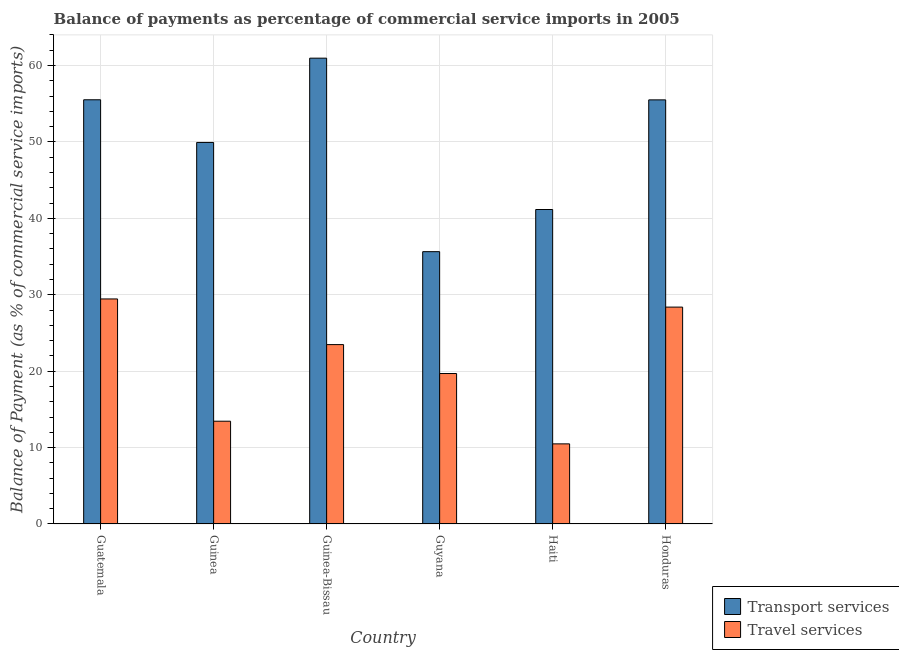How many different coloured bars are there?
Give a very brief answer. 2. What is the label of the 6th group of bars from the left?
Give a very brief answer. Honduras. In how many cases, is the number of bars for a given country not equal to the number of legend labels?
Ensure brevity in your answer.  0. What is the balance of payments of transport services in Honduras?
Offer a very short reply. 55.5. Across all countries, what is the maximum balance of payments of travel services?
Provide a succinct answer. 29.45. Across all countries, what is the minimum balance of payments of travel services?
Make the answer very short. 10.48. In which country was the balance of payments of travel services maximum?
Provide a succinct answer. Guatemala. In which country was the balance of payments of transport services minimum?
Make the answer very short. Guyana. What is the total balance of payments of travel services in the graph?
Your answer should be very brief. 124.93. What is the difference between the balance of payments of transport services in Guinea and that in Honduras?
Offer a very short reply. -5.57. What is the difference between the balance of payments of transport services in Guyana and the balance of payments of travel services in Haiti?
Ensure brevity in your answer.  25.15. What is the average balance of payments of transport services per country?
Make the answer very short. 49.78. What is the difference between the balance of payments of travel services and balance of payments of transport services in Guatemala?
Your answer should be compact. -26.06. In how many countries, is the balance of payments of travel services greater than 46 %?
Make the answer very short. 0. What is the ratio of the balance of payments of travel services in Guinea-Bissau to that in Haiti?
Your answer should be compact. 2.24. Is the balance of payments of transport services in Guyana less than that in Haiti?
Offer a terse response. Yes. Is the difference between the balance of payments of transport services in Guyana and Honduras greater than the difference between the balance of payments of travel services in Guyana and Honduras?
Ensure brevity in your answer.  No. What is the difference between the highest and the second highest balance of payments of transport services?
Ensure brevity in your answer.  5.45. What is the difference between the highest and the lowest balance of payments of transport services?
Ensure brevity in your answer.  25.32. What does the 2nd bar from the left in Guinea-Bissau represents?
Ensure brevity in your answer.  Travel services. What does the 1st bar from the right in Honduras represents?
Offer a terse response. Travel services. Are the values on the major ticks of Y-axis written in scientific E-notation?
Make the answer very short. No. How are the legend labels stacked?
Your response must be concise. Vertical. What is the title of the graph?
Give a very brief answer. Balance of payments as percentage of commercial service imports in 2005. Does "Lowest 10% of population" appear as one of the legend labels in the graph?
Your answer should be very brief. No. What is the label or title of the X-axis?
Offer a very short reply. Country. What is the label or title of the Y-axis?
Keep it short and to the point. Balance of Payment (as % of commercial service imports). What is the Balance of Payment (as % of commercial service imports) in Transport services in Guatemala?
Ensure brevity in your answer.  55.52. What is the Balance of Payment (as % of commercial service imports) in Travel services in Guatemala?
Make the answer very short. 29.45. What is the Balance of Payment (as % of commercial service imports) of Transport services in Guinea?
Ensure brevity in your answer.  49.93. What is the Balance of Payment (as % of commercial service imports) of Travel services in Guinea?
Provide a short and direct response. 13.45. What is the Balance of Payment (as % of commercial service imports) of Transport services in Guinea-Bissau?
Give a very brief answer. 60.96. What is the Balance of Payment (as % of commercial service imports) in Travel services in Guinea-Bissau?
Give a very brief answer. 23.48. What is the Balance of Payment (as % of commercial service imports) of Transport services in Guyana?
Your response must be concise. 35.64. What is the Balance of Payment (as % of commercial service imports) in Travel services in Guyana?
Make the answer very short. 19.69. What is the Balance of Payment (as % of commercial service imports) in Transport services in Haiti?
Your response must be concise. 41.16. What is the Balance of Payment (as % of commercial service imports) of Travel services in Haiti?
Provide a short and direct response. 10.48. What is the Balance of Payment (as % of commercial service imports) in Transport services in Honduras?
Offer a terse response. 55.5. What is the Balance of Payment (as % of commercial service imports) of Travel services in Honduras?
Give a very brief answer. 28.38. Across all countries, what is the maximum Balance of Payment (as % of commercial service imports) of Transport services?
Offer a very short reply. 60.96. Across all countries, what is the maximum Balance of Payment (as % of commercial service imports) in Travel services?
Offer a very short reply. 29.45. Across all countries, what is the minimum Balance of Payment (as % of commercial service imports) in Transport services?
Provide a short and direct response. 35.64. Across all countries, what is the minimum Balance of Payment (as % of commercial service imports) of Travel services?
Your response must be concise. 10.48. What is the total Balance of Payment (as % of commercial service imports) in Transport services in the graph?
Your answer should be compact. 298.7. What is the total Balance of Payment (as % of commercial service imports) of Travel services in the graph?
Ensure brevity in your answer.  124.93. What is the difference between the Balance of Payment (as % of commercial service imports) in Transport services in Guatemala and that in Guinea?
Offer a very short reply. 5.58. What is the difference between the Balance of Payment (as % of commercial service imports) in Travel services in Guatemala and that in Guinea?
Your answer should be very brief. 16. What is the difference between the Balance of Payment (as % of commercial service imports) in Transport services in Guatemala and that in Guinea-Bissau?
Your answer should be compact. -5.45. What is the difference between the Balance of Payment (as % of commercial service imports) of Travel services in Guatemala and that in Guinea-Bissau?
Provide a succinct answer. 5.98. What is the difference between the Balance of Payment (as % of commercial service imports) in Transport services in Guatemala and that in Guyana?
Offer a very short reply. 19.88. What is the difference between the Balance of Payment (as % of commercial service imports) of Travel services in Guatemala and that in Guyana?
Make the answer very short. 9.76. What is the difference between the Balance of Payment (as % of commercial service imports) of Transport services in Guatemala and that in Haiti?
Your response must be concise. 14.36. What is the difference between the Balance of Payment (as % of commercial service imports) of Travel services in Guatemala and that in Haiti?
Your answer should be very brief. 18.97. What is the difference between the Balance of Payment (as % of commercial service imports) of Transport services in Guatemala and that in Honduras?
Make the answer very short. 0.01. What is the difference between the Balance of Payment (as % of commercial service imports) in Travel services in Guatemala and that in Honduras?
Provide a short and direct response. 1.07. What is the difference between the Balance of Payment (as % of commercial service imports) of Transport services in Guinea and that in Guinea-Bissau?
Make the answer very short. -11.03. What is the difference between the Balance of Payment (as % of commercial service imports) of Travel services in Guinea and that in Guinea-Bissau?
Your answer should be very brief. -10.03. What is the difference between the Balance of Payment (as % of commercial service imports) in Transport services in Guinea and that in Guyana?
Provide a succinct answer. 14.3. What is the difference between the Balance of Payment (as % of commercial service imports) in Travel services in Guinea and that in Guyana?
Offer a terse response. -6.24. What is the difference between the Balance of Payment (as % of commercial service imports) in Transport services in Guinea and that in Haiti?
Offer a terse response. 8.78. What is the difference between the Balance of Payment (as % of commercial service imports) in Travel services in Guinea and that in Haiti?
Provide a succinct answer. 2.97. What is the difference between the Balance of Payment (as % of commercial service imports) of Transport services in Guinea and that in Honduras?
Your answer should be compact. -5.57. What is the difference between the Balance of Payment (as % of commercial service imports) in Travel services in Guinea and that in Honduras?
Your answer should be compact. -14.93. What is the difference between the Balance of Payment (as % of commercial service imports) in Transport services in Guinea-Bissau and that in Guyana?
Offer a very short reply. 25.32. What is the difference between the Balance of Payment (as % of commercial service imports) in Travel services in Guinea-Bissau and that in Guyana?
Offer a terse response. 3.79. What is the difference between the Balance of Payment (as % of commercial service imports) in Transport services in Guinea-Bissau and that in Haiti?
Provide a succinct answer. 19.81. What is the difference between the Balance of Payment (as % of commercial service imports) of Travel services in Guinea-Bissau and that in Haiti?
Offer a terse response. 12.99. What is the difference between the Balance of Payment (as % of commercial service imports) of Transport services in Guinea-Bissau and that in Honduras?
Offer a terse response. 5.46. What is the difference between the Balance of Payment (as % of commercial service imports) of Travel services in Guinea-Bissau and that in Honduras?
Provide a short and direct response. -4.91. What is the difference between the Balance of Payment (as % of commercial service imports) of Transport services in Guyana and that in Haiti?
Your response must be concise. -5.52. What is the difference between the Balance of Payment (as % of commercial service imports) in Travel services in Guyana and that in Haiti?
Offer a terse response. 9.2. What is the difference between the Balance of Payment (as % of commercial service imports) in Transport services in Guyana and that in Honduras?
Keep it short and to the point. -19.87. What is the difference between the Balance of Payment (as % of commercial service imports) in Travel services in Guyana and that in Honduras?
Ensure brevity in your answer.  -8.69. What is the difference between the Balance of Payment (as % of commercial service imports) in Transport services in Haiti and that in Honduras?
Offer a terse response. -14.35. What is the difference between the Balance of Payment (as % of commercial service imports) of Travel services in Haiti and that in Honduras?
Provide a succinct answer. -17.9. What is the difference between the Balance of Payment (as % of commercial service imports) in Transport services in Guatemala and the Balance of Payment (as % of commercial service imports) in Travel services in Guinea?
Your answer should be very brief. 42.07. What is the difference between the Balance of Payment (as % of commercial service imports) of Transport services in Guatemala and the Balance of Payment (as % of commercial service imports) of Travel services in Guinea-Bissau?
Make the answer very short. 32.04. What is the difference between the Balance of Payment (as % of commercial service imports) in Transport services in Guatemala and the Balance of Payment (as % of commercial service imports) in Travel services in Guyana?
Your answer should be very brief. 35.83. What is the difference between the Balance of Payment (as % of commercial service imports) of Transport services in Guatemala and the Balance of Payment (as % of commercial service imports) of Travel services in Haiti?
Offer a terse response. 45.03. What is the difference between the Balance of Payment (as % of commercial service imports) of Transport services in Guatemala and the Balance of Payment (as % of commercial service imports) of Travel services in Honduras?
Provide a short and direct response. 27.13. What is the difference between the Balance of Payment (as % of commercial service imports) of Transport services in Guinea and the Balance of Payment (as % of commercial service imports) of Travel services in Guinea-Bissau?
Ensure brevity in your answer.  26.46. What is the difference between the Balance of Payment (as % of commercial service imports) in Transport services in Guinea and the Balance of Payment (as % of commercial service imports) in Travel services in Guyana?
Offer a terse response. 30.24. What is the difference between the Balance of Payment (as % of commercial service imports) of Transport services in Guinea and the Balance of Payment (as % of commercial service imports) of Travel services in Haiti?
Your answer should be very brief. 39.45. What is the difference between the Balance of Payment (as % of commercial service imports) in Transport services in Guinea and the Balance of Payment (as % of commercial service imports) in Travel services in Honduras?
Your answer should be compact. 21.55. What is the difference between the Balance of Payment (as % of commercial service imports) of Transport services in Guinea-Bissau and the Balance of Payment (as % of commercial service imports) of Travel services in Guyana?
Ensure brevity in your answer.  41.27. What is the difference between the Balance of Payment (as % of commercial service imports) of Transport services in Guinea-Bissau and the Balance of Payment (as % of commercial service imports) of Travel services in Haiti?
Offer a very short reply. 50.48. What is the difference between the Balance of Payment (as % of commercial service imports) in Transport services in Guinea-Bissau and the Balance of Payment (as % of commercial service imports) in Travel services in Honduras?
Offer a terse response. 32.58. What is the difference between the Balance of Payment (as % of commercial service imports) in Transport services in Guyana and the Balance of Payment (as % of commercial service imports) in Travel services in Haiti?
Provide a succinct answer. 25.15. What is the difference between the Balance of Payment (as % of commercial service imports) of Transport services in Guyana and the Balance of Payment (as % of commercial service imports) of Travel services in Honduras?
Make the answer very short. 7.25. What is the difference between the Balance of Payment (as % of commercial service imports) of Transport services in Haiti and the Balance of Payment (as % of commercial service imports) of Travel services in Honduras?
Offer a terse response. 12.77. What is the average Balance of Payment (as % of commercial service imports) of Transport services per country?
Provide a succinct answer. 49.78. What is the average Balance of Payment (as % of commercial service imports) of Travel services per country?
Offer a terse response. 20.82. What is the difference between the Balance of Payment (as % of commercial service imports) in Transport services and Balance of Payment (as % of commercial service imports) in Travel services in Guatemala?
Provide a short and direct response. 26.06. What is the difference between the Balance of Payment (as % of commercial service imports) in Transport services and Balance of Payment (as % of commercial service imports) in Travel services in Guinea?
Provide a short and direct response. 36.48. What is the difference between the Balance of Payment (as % of commercial service imports) in Transport services and Balance of Payment (as % of commercial service imports) in Travel services in Guinea-Bissau?
Offer a very short reply. 37.49. What is the difference between the Balance of Payment (as % of commercial service imports) of Transport services and Balance of Payment (as % of commercial service imports) of Travel services in Guyana?
Make the answer very short. 15.95. What is the difference between the Balance of Payment (as % of commercial service imports) in Transport services and Balance of Payment (as % of commercial service imports) in Travel services in Haiti?
Your answer should be compact. 30.67. What is the difference between the Balance of Payment (as % of commercial service imports) of Transport services and Balance of Payment (as % of commercial service imports) of Travel services in Honduras?
Make the answer very short. 27.12. What is the ratio of the Balance of Payment (as % of commercial service imports) of Transport services in Guatemala to that in Guinea?
Your response must be concise. 1.11. What is the ratio of the Balance of Payment (as % of commercial service imports) in Travel services in Guatemala to that in Guinea?
Give a very brief answer. 2.19. What is the ratio of the Balance of Payment (as % of commercial service imports) of Transport services in Guatemala to that in Guinea-Bissau?
Your answer should be compact. 0.91. What is the ratio of the Balance of Payment (as % of commercial service imports) in Travel services in Guatemala to that in Guinea-Bissau?
Provide a succinct answer. 1.25. What is the ratio of the Balance of Payment (as % of commercial service imports) of Transport services in Guatemala to that in Guyana?
Provide a succinct answer. 1.56. What is the ratio of the Balance of Payment (as % of commercial service imports) of Travel services in Guatemala to that in Guyana?
Offer a terse response. 1.5. What is the ratio of the Balance of Payment (as % of commercial service imports) of Transport services in Guatemala to that in Haiti?
Give a very brief answer. 1.35. What is the ratio of the Balance of Payment (as % of commercial service imports) of Travel services in Guatemala to that in Haiti?
Your answer should be compact. 2.81. What is the ratio of the Balance of Payment (as % of commercial service imports) in Travel services in Guatemala to that in Honduras?
Offer a terse response. 1.04. What is the ratio of the Balance of Payment (as % of commercial service imports) in Transport services in Guinea to that in Guinea-Bissau?
Keep it short and to the point. 0.82. What is the ratio of the Balance of Payment (as % of commercial service imports) of Travel services in Guinea to that in Guinea-Bissau?
Your answer should be very brief. 0.57. What is the ratio of the Balance of Payment (as % of commercial service imports) in Transport services in Guinea to that in Guyana?
Ensure brevity in your answer.  1.4. What is the ratio of the Balance of Payment (as % of commercial service imports) in Travel services in Guinea to that in Guyana?
Keep it short and to the point. 0.68. What is the ratio of the Balance of Payment (as % of commercial service imports) of Transport services in Guinea to that in Haiti?
Your answer should be compact. 1.21. What is the ratio of the Balance of Payment (as % of commercial service imports) of Travel services in Guinea to that in Haiti?
Your answer should be compact. 1.28. What is the ratio of the Balance of Payment (as % of commercial service imports) of Transport services in Guinea to that in Honduras?
Your response must be concise. 0.9. What is the ratio of the Balance of Payment (as % of commercial service imports) in Travel services in Guinea to that in Honduras?
Ensure brevity in your answer.  0.47. What is the ratio of the Balance of Payment (as % of commercial service imports) in Transport services in Guinea-Bissau to that in Guyana?
Offer a very short reply. 1.71. What is the ratio of the Balance of Payment (as % of commercial service imports) in Travel services in Guinea-Bissau to that in Guyana?
Keep it short and to the point. 1.19. What is the ratio of the Balance of Payment (as % of commercial service imports) in Transport services in Guinea-Bissau to that in Haiti?
Offer a terse response. 1.48. What is the ratio of the Balance of Payment (as % of commercial service imports) of Travel services in Guinea-Bissau to that in Haiti?
Provide a short and direct response. 2.24. What is the ratio of the Balance of Payment (as % of commercial service imports) of Transport services in Guinea-Bissau to that in Honduras?
Your answer should be compact. 1.1. What is the ratio of the Balance of Payment (as % of commercial service imports) of Travel services in Guinea-Bissau to that in Honduras?
Your response must be concise. 0.83. What is the ratio of the Balance of Payment (as % of commercial service imports) in Transport services in Guyana to that in Haiti?
Your response must be concise. 0.87. What is the ratio of the Balance of Payment (as % of commercial service imports) in Travel services in Guyana to that in Haiti?
Ensure brevity in your answer.  1.88. What is the ratio of the Balance of Payment (as % of commercial service imports) of Transport services in Guyana to that in Honduras?
Offer a very short reply. 0.64. What is the ratio of the Balance of Payment (as % of commercial service imports) of Travel services in Guyana to that in Honduras?
Offer a very short reply. 0.69. What is the ratio of the Balance of Payment (as % of commercial service imports) in Transport services in Haiti to that in Honduras?
Provide a short and direct response. 0.74. What is the ratio of the Balance of Payment (as % of commercial service imports) of Travel services in Haiti to that in Honduras?
Provide a succinct answer. 0.37. What is the difference between the highest and the second highest Balance of Payment (as % of commercial service imports) of Transport services?
Ensure brevity in your answer.  5.45. What is the difference between the highest and the second highest Balance of Payment (as % of commercial service imports) of Travel services?
Make the answer very short. 1.07. What is the difference between the highest and the lowest Balance of Payment (as % of commercial service imports) of Transport services?
Provide a succinct answer. 25.32. What is the difference between the highest and the lowest Balance of Payment (as % of commercial service imports) in Travel services?
Your answer should be very brief. 18.97. 